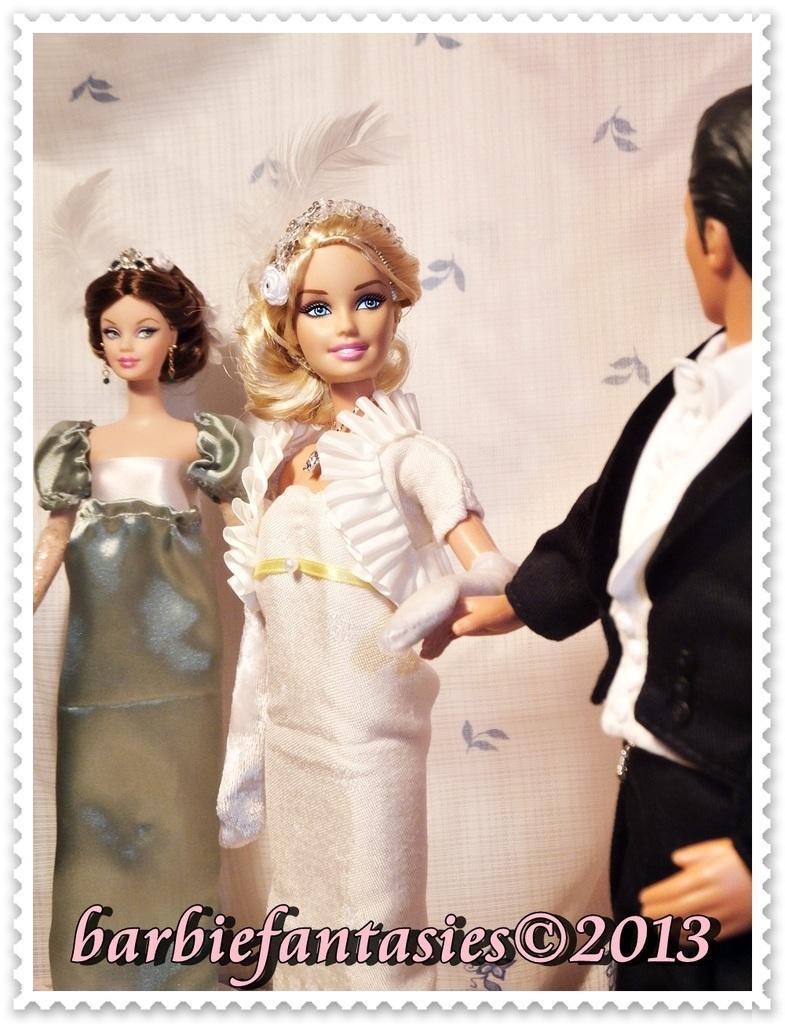In one or two sentences, can you explain what this image depicts? Two barbie dolls and a man doll are with a background screen. 